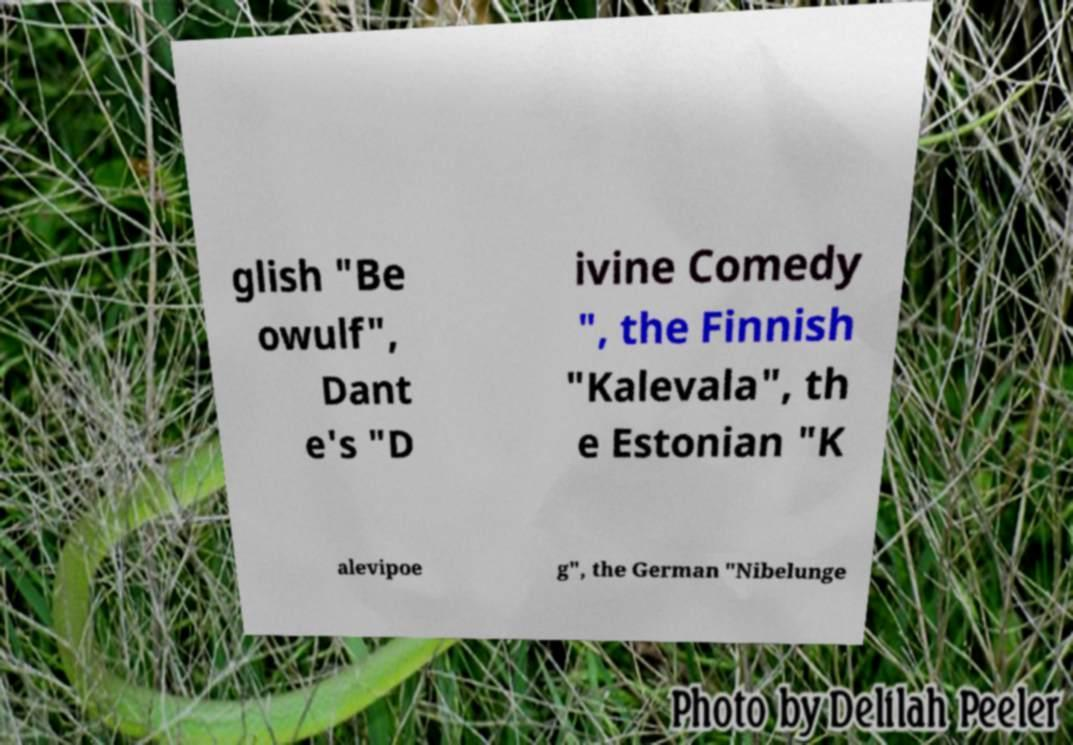Please identify and transcribe the text found in this image. glish "Be owulf", Dant e's "D ivine Comedy ", the Finnish "Kalevala", th e Estonian "K alevipoe g", the German "Nibelunge 